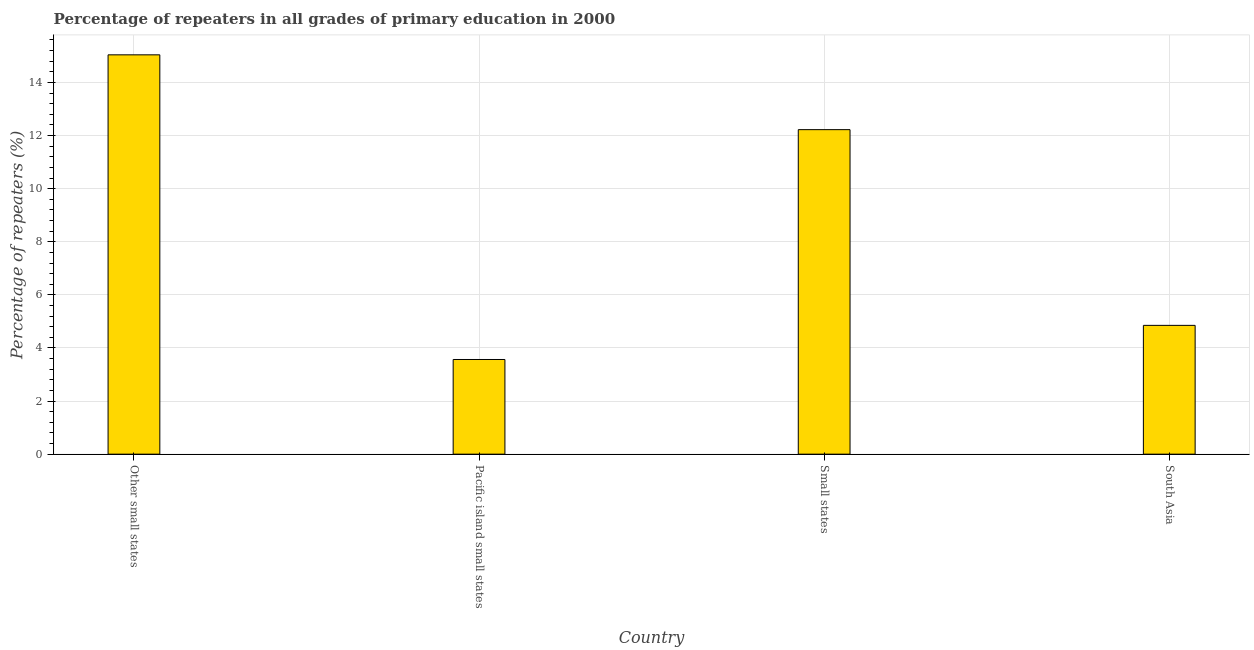What is the title of the graph?
Provide a short and direct response. Percentage of repeaters in all grades of primary education in 2000. What is the label or title of the X-axis?
Provide a succinct answer. Country. What is the label or title of the Y-axis?
Keep it short and to the point. Percentage of repeaters (%). What is the percentage of repeaters in primary education in South Asia?
Ensure brevity in your answer.  4.85. Across all countries, what is the maximum percentage of repeaters in primary education?
Offer a very short reply. 15.04. Across all countries, what is the minimum percentage of repeaters in primary education?
Ensure brevity in your answer.  3.57. In which country was the percentage of repeaters in primary education maximum?
Provide a succinct answer. Other small states. In which country was the percentage of repeaters in primary education minimum?
Make the answer very short. Pacific island small states. What is the sum of the percentage of repeaters in primary education?
Make the answer very short. 35.68. What is the difference between the percentage of repeaters in primary education in Pacific island small states and South Asia?
Provide a succinct answer. -1.28. What is the average percentage of repeaters in primary education per country?
Keep it short and to the point. 8.92. What is the median percentage of repeaters in primary education?
Provide a succinct answer. 8.54. In how many countries, is the percentage of repeaters in primary education greater than 13.6 %?
Give a very brief answer. 1. What is the ratio of the percentage of repeaters in primary education in Other small states to that in South Asia?
Provide a short and direct response. 3.1. Is the difference between the percentage of repeaters in primary education in Pacific island small states and South Asia greater than the difference between any two countries?
Offer a terse response. No. What is the difference between the highest and the second highest percentage of repeaters in primary education?
Offer a very short reply. 2.82. Is the sum of the percentage of repeaters in primary education in Other small states and South Asia greater than the maximum percentage of repeaters in primary education across all countries?
Keep it short and to the point. Yes. What is the difference between the highest and the lowest percentage of repeaters in primary education?
Give a very brief answer. 11.47. In how many countries, is the percentage of repeaters in primary education greater than the average percentage of repeaters in primary education taken over all countries?
Offer a very short reply. 2. Are all the bars in the graph horizontal?
Your response must be concise. No. How many countries are there in the graph?
Provide a succinct answer. 4. What is the Percentage of repeaters (%) in Other small states?
Your answer should be compact. 15.04. What is the Percentage of repeaters (%) of Pacific island small states?
Your answer should be compact. 3.57. What is the Percentage of repeaters (%) in Small states?
Your answer should be compact. 12.22. What is the Percentage of repeaters (%) of South Asia?
Your answer should be compact. 4.85. What is the difference between the Percentage of repeaters (%) in Other small states and Pacific island small states?
Provide a short and direct response. 11.47. What is the difference between the Percentage of repeaters (%) in Other small states and Small states?
Provide a short and direct response. 2.82. What is the difference between the Percentage of repeaters (%) in Other small states and South Asia?
Your answer should be compact. 10.19. What is the difference between the Percentage of repeaters (%) in Pacific island small states and Small states?
Provide a succinct answer. -8.66. What is the difference between the Percentage of repeaters (%) in Pacific island small states and South Asia?
Keep it short and to the point. -1.28. What is the difference between the Percentage of repeaters (%) in Small states and South Asia?
Keep it short and to the point. 7.37. What is the ratio of the Percentage of repeaters (%) in Other small states to that in Pacific island small states?
Make the answer very short. 4.22. What is the ratio of the Percentage of repeaters (%) in Other small states to that in Small states?
Make the answer very short. 1.23. What is the ratio of the Percentage of repeaters (%) in Other small states to that in South Asia?
Provide a succinct answer. 3.1. What is the ratio of the Percentage of repeaters (%) in Pacific island small states to that in Small states?
Your answer should be compact. 0.29. What is the ratio of the Percentage of repeaters (%) in Pacific island small states to that in South Asia?
Offer a very short reply. 0.73. What is the ratio of the Percentage of repeaters (%) in Small states to that in South Asia?
Provide a short and direct response. 2.52. 